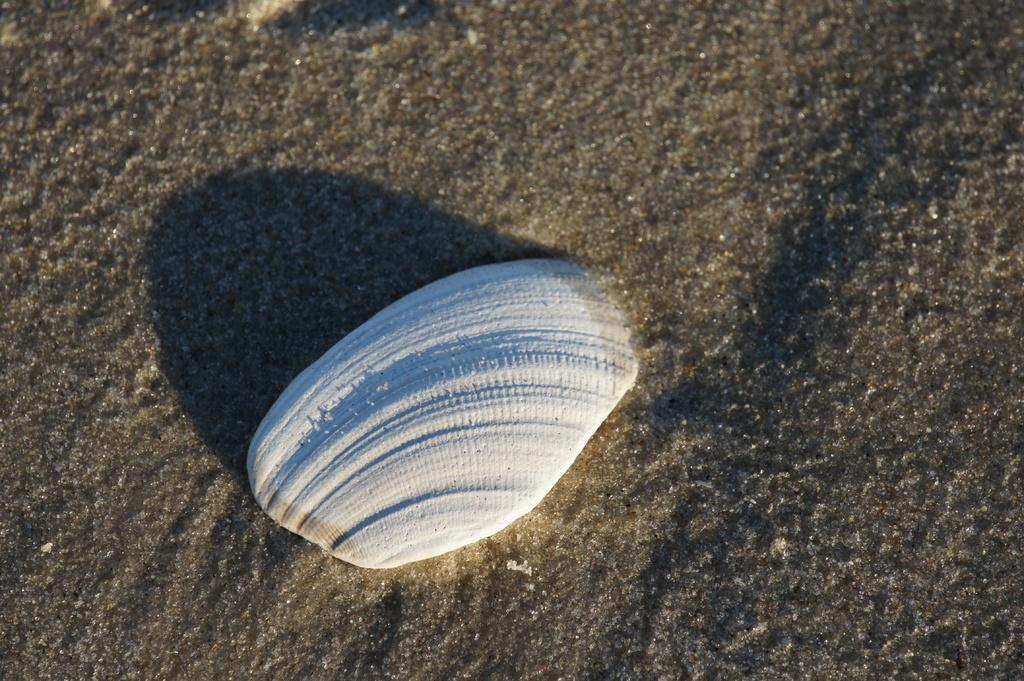What is the main object in the image? There is a white shell in the image. What is the shell resting on? The shell is on sand. What type of line can be seen connecting the shell to the stick in the image? There is no stick or line present in the image; it only features a white shell on sand. 